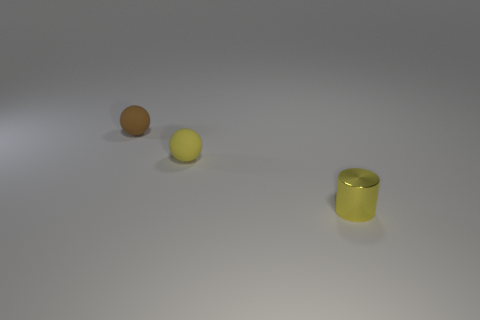Add 2 tiny purple cubes. How many objects exist? 5 Subtract all balls. How many objects are left? 1 Add 3 tiny yellow things. How many tiny yellow things are left? 5 Add 3 small cyan shiny things. How many small cyan shiny things exist? 3 Subtract 0 blue spheres. How many objects are left? 3 Subtract all large yellow rubber spheres. Subtract all small matte spheres. How many objects are left? 1 